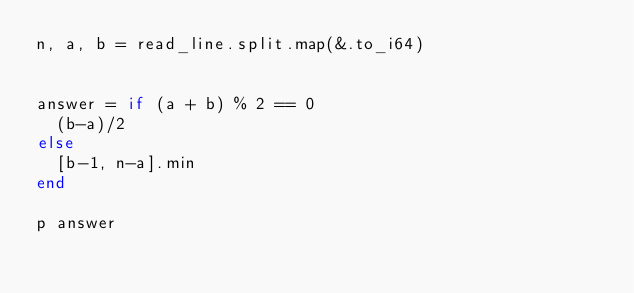Convert code to text. <code><loc_0><loc_0><loc_500><loc_500><_Crystal_>n, a, b = read_line.split.map(&.to_i64)


answer = if (a + b) % 2 == 0
  (b-a)/2
else
  [b-1, n-a].min
end

p answer
</code> 